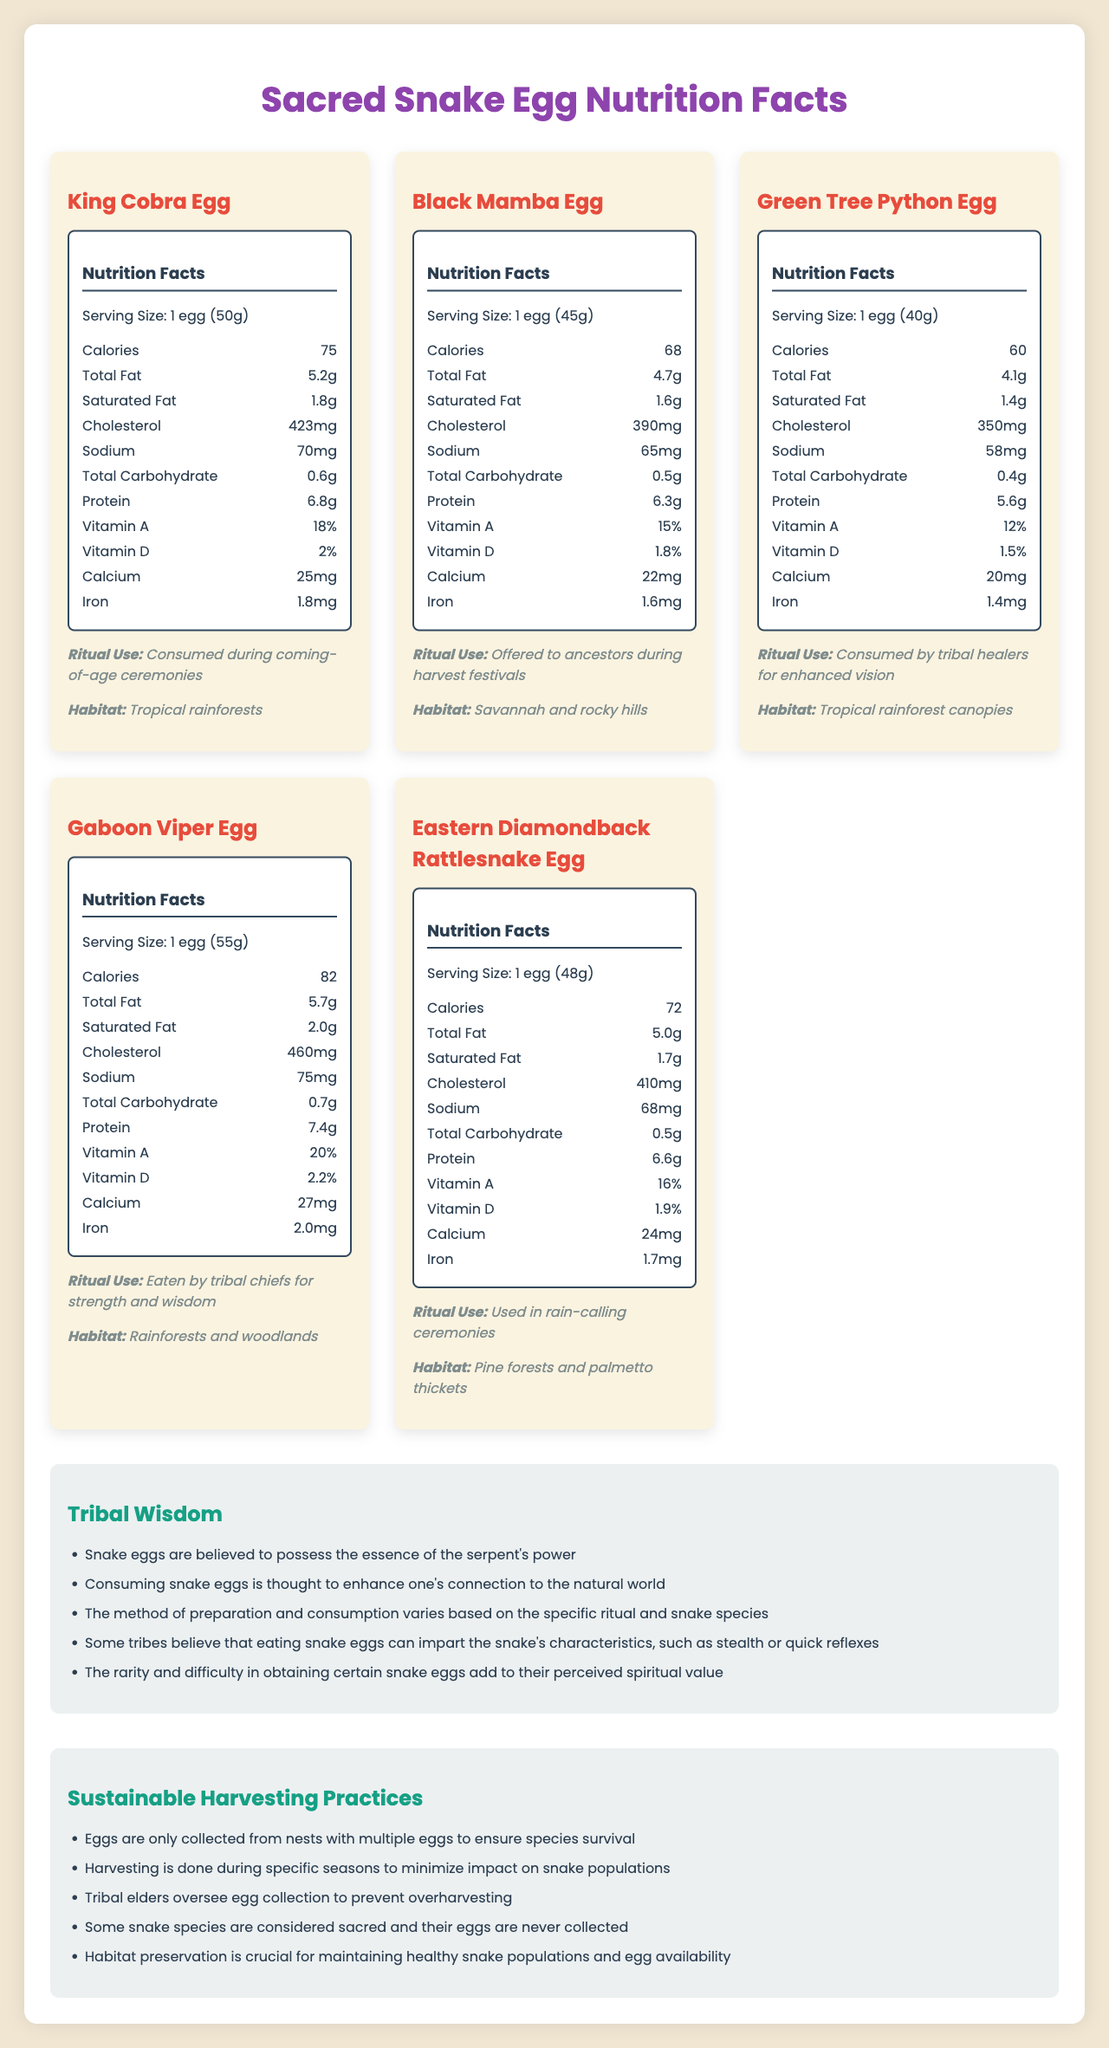What is the serving size of a King Cobra Egg? The serving size details are listed under each egg type, and for King Cobra Egg, it is mentioned as 1 egg (50g).
Answer: 1 egg (50g) Which snake egg type has the highest protein content? The Gaboon Viper Egg has 7.4g of protein, which is the highest among the listed eggs.
Answer: Gaboon Viper Egg How much cholesterol does the Green Tree Python Egg contain? The cholesterol content for each egg is listed, and for the Green Tree Python Egg, it is 350mg.
Answer: 350mg What is the ritual use of the Eastern Diamondback Rattlesnake Egg? Ritual use for each snake egg is mentioned, and for the Eastern Diamondback Rattlesnake Egg, it is used in rain-calling ceremonies.
Answer: Used in rain-calling ceremonies Which snake egg is consumed by tribal healers for enhanced vision? The document specifies that the Green Tree Python Egg is consumed by tribal healers for enhanced vision.
Answer: Green Tree Python Egg Which egg type is consumed during coming-of-age ceremonies? A. King Cobra Egg B. Gaboon Viper Egg C. Black Mamba Egg D. Eastern Diamondback Rattlesnake Egg The ritual use for King Cobra Egg is stated as consumed during coming-of-age ceremonies.
Answer: A. King Cobra Egg Which egg type is offered to ancestors during harvest festivals? A. Green Tree Python Egg B. Black Mamba Egg C. Gaboon Viper Egg D. Eastern Diamondback Rattlesnake Egg The document specifies that Black Mamba Egg is offered to ancestors during harvest festivals.
Answer: B. Black Mamba Egg Is the sodium content of the Eastern Diamondback Rattlesnake Egg higher than that of the Black Mamba Egg? The sodium content of the Eastern Diamondback Rattlesnake Egg is 68mg, which is higher than the Black Mamba Egg's 65mg.
Answer: Yes Summarize the document's main purpose. It presents detailed nutrition facts for King Cobra, Black Mamba, Green Tree Python, Gaboon Viper, and Eastern Diamondback Rattlesnake eggs, their ritual uses, and habitats. Additionally, it includes tribal wisdom on the significance of snake eggs and sustainable harvesting guidelines to ensure species survival.
Answer: The document provides nutritional information and ritual uses for various snake eggs consumed in tribal rituals, along with details on tribal wisdom and sustainable harvesting practices. What is the specific habitat of the Black Mamba Egg? The habitat information is listed under each egg type, and for the Black Mamba Egg, it is "Savannah and rocky hills".
Answer: Savannah and rocky hills What is the total fat content of the Gaboon Viper Egg? The total fat content for each egg is listed, and for the Gaboon Viper Egg, it is 5.7g.
Answer: 5.7g Which eggs have a higher iron content than the King Cobra Egg? The King Cobra Egg has 1.8mg of iron, and the Gaboon Viper Egg, with 2.0mg of iron, is the only egg with a higher iron content.
Answer: Gaboon Viper Egg How much vitamin D is present in the King Cobra Egg? The vitamin D content for each egg is listed in percentages, and the King Cobra Egg contains 2% of the daily value.
Answer: 2% Describe the sustainable harvesting practices mentioned in the document. The document outlines various sustainable practices to ensure minimal impact on snake populations and preserve their habitats, emphasizing the importance of not overharvesting and respecting certain sacred species.
Answer: Sustainable harvesting involves collecting eggs only from nests with multiple eggs, during specific seasons, under the supervision of tribal elders, preserving habitats, and respecting sacred snake species. What makes snake eggs significant in tribal rituals? The document mentions various tribal wisdom points that highlight the spiritual and symbolic importance of snake eggs in rituals.
Answer: The consumption of snake eggs is believed to enhance one’s connection to the natural world, impart the snake's characteristics, and hold spiritual value due to their rarity and the essence of the serpent's power. What are the energy benefits of consuming the Green Tree Python Egg compared to other eggs? The document provides calorie content for each egg but does not elaborate on specific energy benefits or comparisons.
Answer: Not enough information Which snake egg contains the highest amount of calcium? The Gaboon Viper Egg contains 27mg of calcium, the highest among the listed eggs.
Answer: Gaboon Viper Egg 